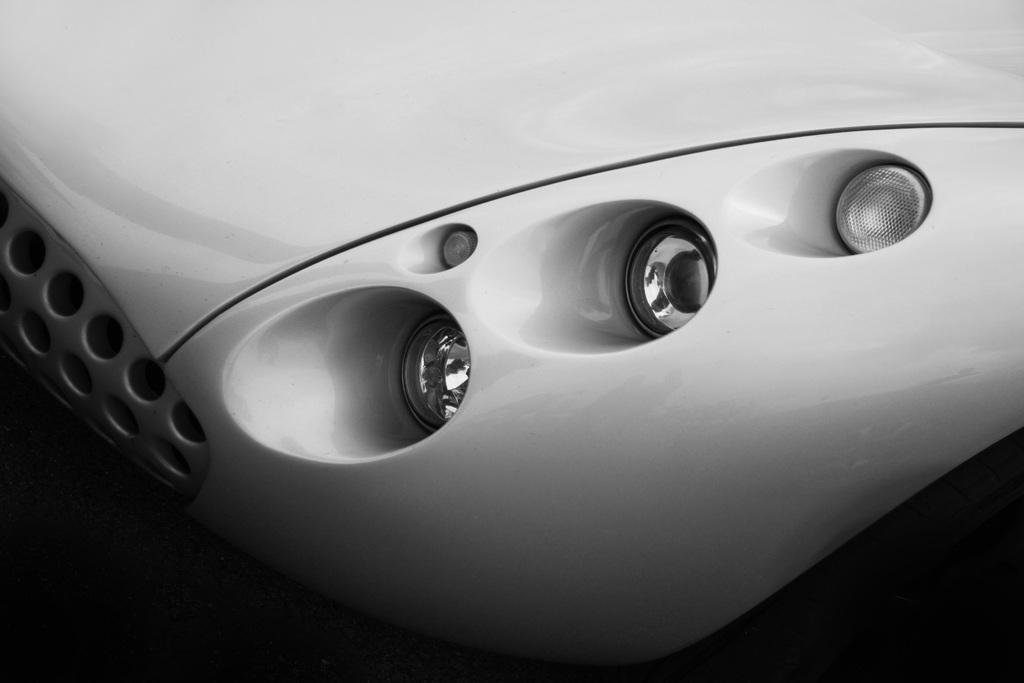Please provide a concise description of this image. This is a black and white image. This picture is front view of a vehicle. In this picture we can see the lights and bolt. 